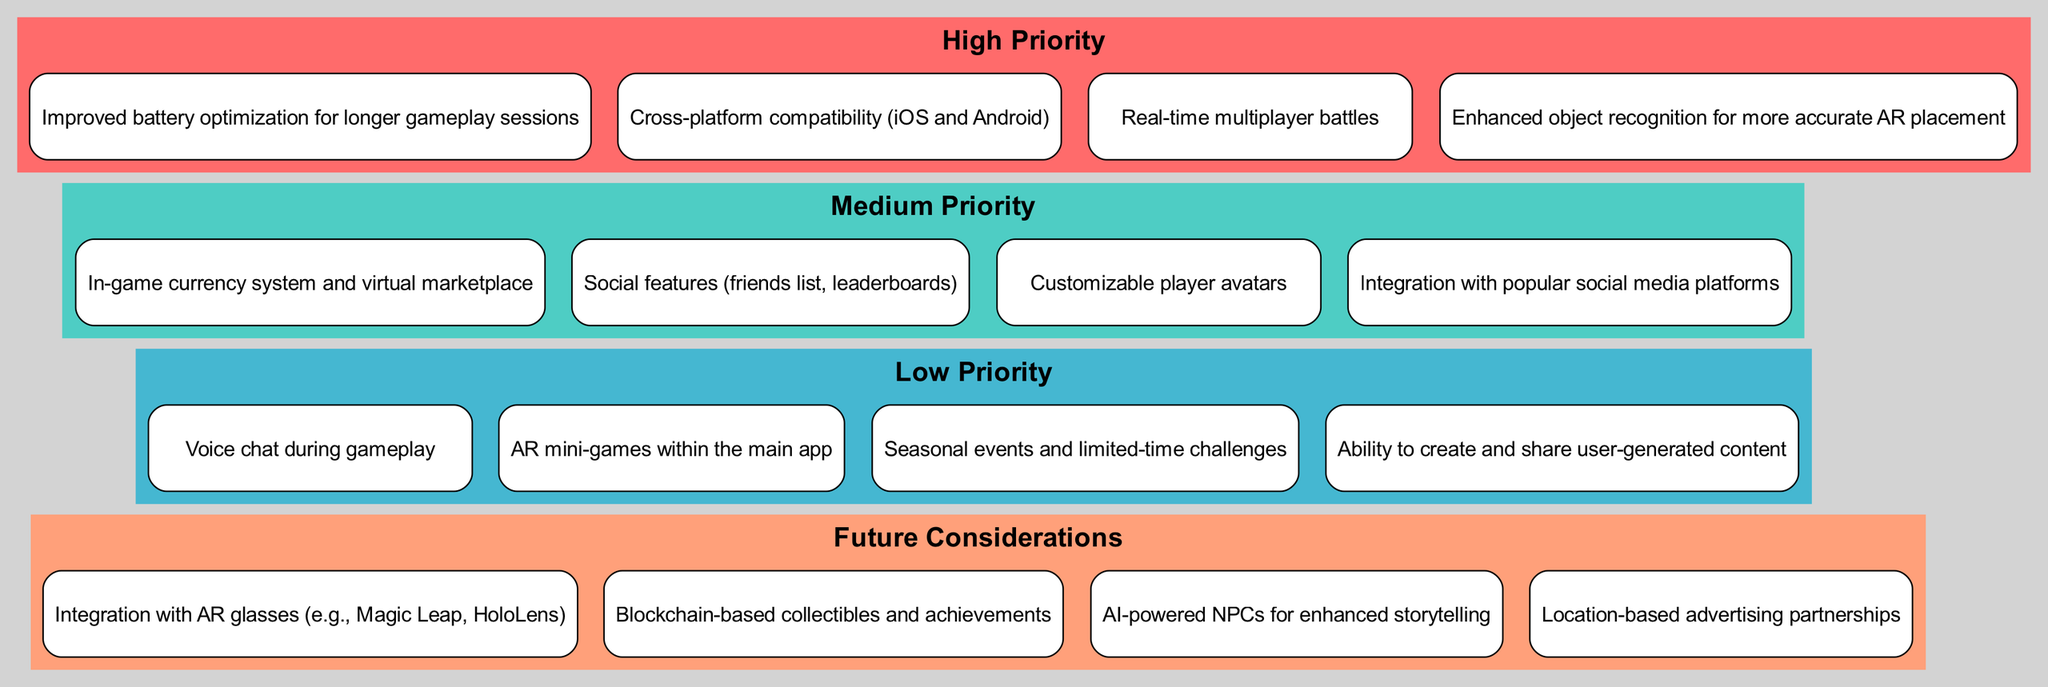What are the items listed under High Priority? The diagram outlines four items categorized under High Priority: "Improved battery optimization for longer gameplay sessions," "Cross-platform compatibility (iOS and Android)," "Real-time multiplayer battles," and "Enhanced object recognition for more accurate AR placement."
Answer: Improved battery optimization for longer gameplay sessions, Cross-platform compatibility (iOS and Android), Real-time multiplayer battles, Enhanced object recognition for more accurate AR placement How many items are listed in Medium Priority? The Medium Priority section contains four items listed: "In-game currency system and virtual marketplace," "Social features (friends list, leaderboards)," "Customizable player avatars," and "Integration with popular social media platforms." Therefore, the answer is four.
Answer: 4 Which priority level has the most items? By inspecting the diagram, "High Priority" and "Medium Priority" both contain four items each, while "Low Priority" and "Future Considerations" each have four items as well. Thus, no priority level has more items than the others; they are all equal.
Answer: None What is the second item listed under Low Priority? In the Low Priority section, the items are listed in order: "Voice chat during gameplay" is the first, and "AR mini-games within the main app" is the second item. Therefore, this is the answer.
Answer: AR mini-games within the main app Which priority contains a focus on future technology? Observing the "Future Considerations" cluster, it contains items that discuss potential future technologies such as "Integration with AR glasses (e.g., Magic Leap, HoloLens)," which indicates a focus on innovative technology.
Answer: Future Considerations How many total categories or priorities are displayed in the diagram? The diagram outlines four distinct categories or priorities: "High Priority," "Medium Priority," "Low Priority," and "Future Considerations." Thus, the total number of categories is four.
Answer: 4 What is the main theme of items listed under Future Considerations? Under Future Considerations, the main theme revolves around innovative technology and integration with advanced systems, such as “Integration with AR glasses” and “Blockchain-based collectibles and achievements.” This shows a forward-looking perspective on AR applications.
Answer: Innovative technology Are there any social features mentioned and if so, what is the priority? Yes, the item "Social features (friends list, leaderboards)" is mentioned, and it is categorized under Medium Priority.
Answer: Medium Priority 